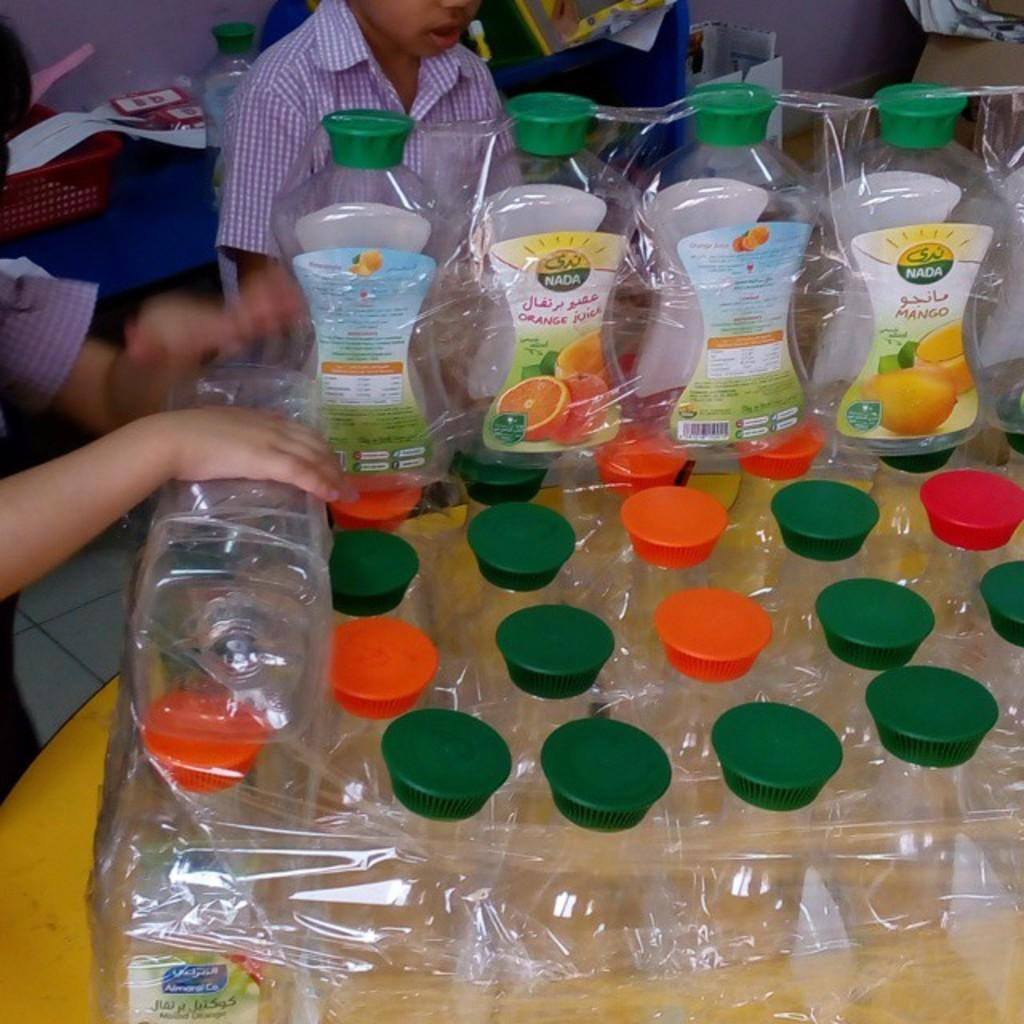<image>
Share a concise interpretation of the image provided. the word Nada is on the clear bottle 